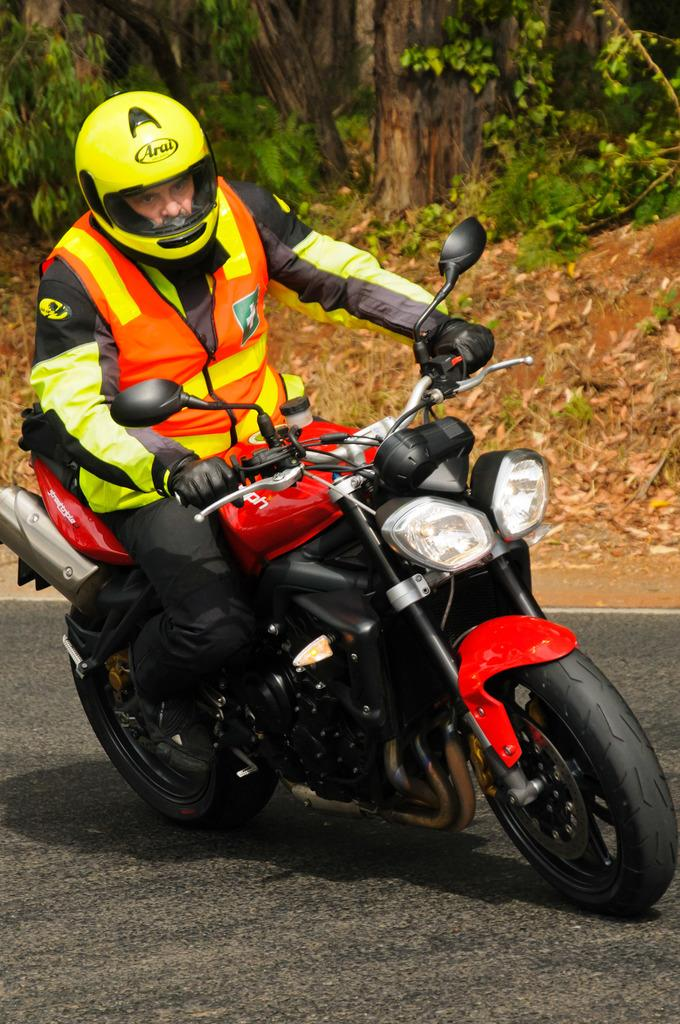What type of vegetation can be seen in the image? There are trees and plants in the image. How are the trees depicted in the image? The trees appear to be truncated in the image. Can you describe the person wearing a helmet in the image? There is a person wearing a helmet in the image, and they are riding a motorcycle. What type of cloth is being used for the voyage in the image? There is no voyage or cloth present in the image; it features trees, plants, and a person riding a motorcycle. 